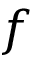Convert formula to latex. <formula><loc_0><loc_0><loc_500><loc_500>f</formula> 